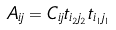<formula> <loc_0><loc_0><loc_500><loc_500>A _ { i j } = C _ { i j } t _ { i _ { 2 } j _ { 2 } } t _ { i _ { 1 } j _ { 1 } }</formula> 